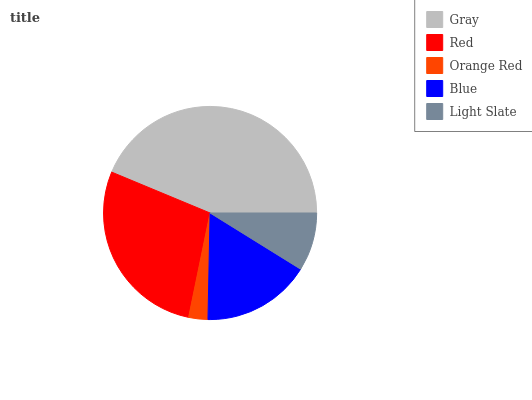Is Orange Red the minimum?
Answer yes or no. Yes. Is Gray the maximum?
Answer yes or no. Yes. Is Red the minimum?
Answer yes or no. No. Is Red the maximum?
Answer yes or no. No. Is Gray greater than Red?
Answer yes or no. Yes. Is Red less than Gray?
Answer yes or no. Yes. Is Red greater than Gray?
Answer yes or no. No. Is Gray less than Red?
Answer yes or no. No. Is Blue the high median?
Answer yes or no. Yes. Is Blue the low median?
Answer yes or no. Yes. Is Light Slate the high median?
Answer yes or no. No. Is Red the low median?
Answer yes or no. No. 